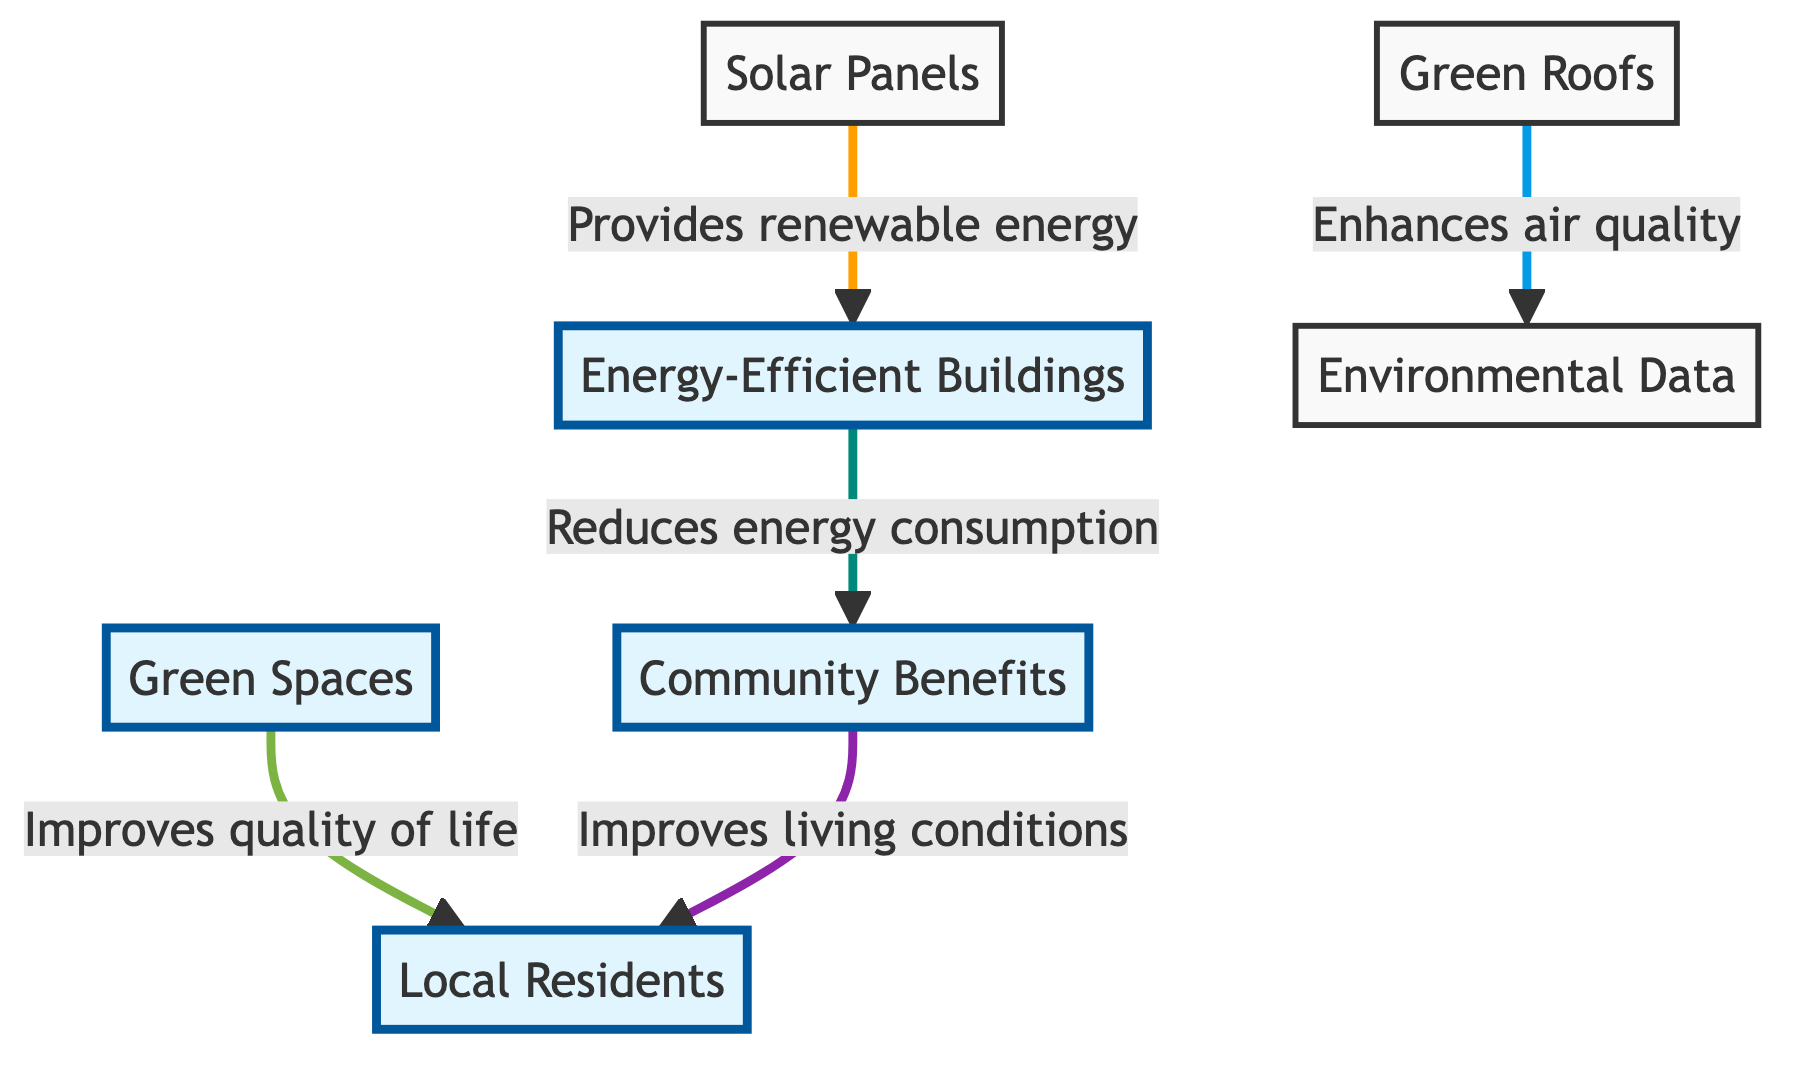What is the main feature that connects to Energy-Efficient Buildings? The diagram indicates that Solar Panels provide renewable energy, which connects to Energy-Efficient Buildings.
Answer: Solar Panels How many main categories are there in this diagram? There are four main categories: Energy-Efficient Buildings, Green Spaces, Community Benefits, and Environmental Data.
Answer: Four Which node shows a benefit to local residents? The Community Benefits node specifically highlights improvements to the living conditions of local residents.
Answer: Community Benefits What is one method to enhance air quality depicted in the diagram? The diagram indicates that Green Roofs are one method to enhance air quality.
Answer: Green Roofs How do Green Spaces contribute to local residents according to the diagram? Green Spaces improve the quality of life for local residents, as indicated by the arrow directed towards Local Residents.
Answer: Improves quality of life What is the relationship between Green Roofs and Environmental Data? The diagram shows that Green Roofs enhance air quality, which is represented under Environmental Data.
Answer: Enhances air quality What (or who) benefits from the improvements in living conditions? According to the flowchart, Local Residents benefit from the improvements in living conditions depicted in the Community Benefits node.
Answer: Local Residents Which element provides a pathway to reduce energy consumption? The flow from Energy-Efficient Buildings shows that they reduce energy consumption, leading toward Community Benefits.
Answer: Energy-Efficient Buildings What type of diagram is represented here? The diagram type is a Textbook Diagram, as it illustrates relationships and benefits in a structured manner.
Answer: Textbook Diagram 